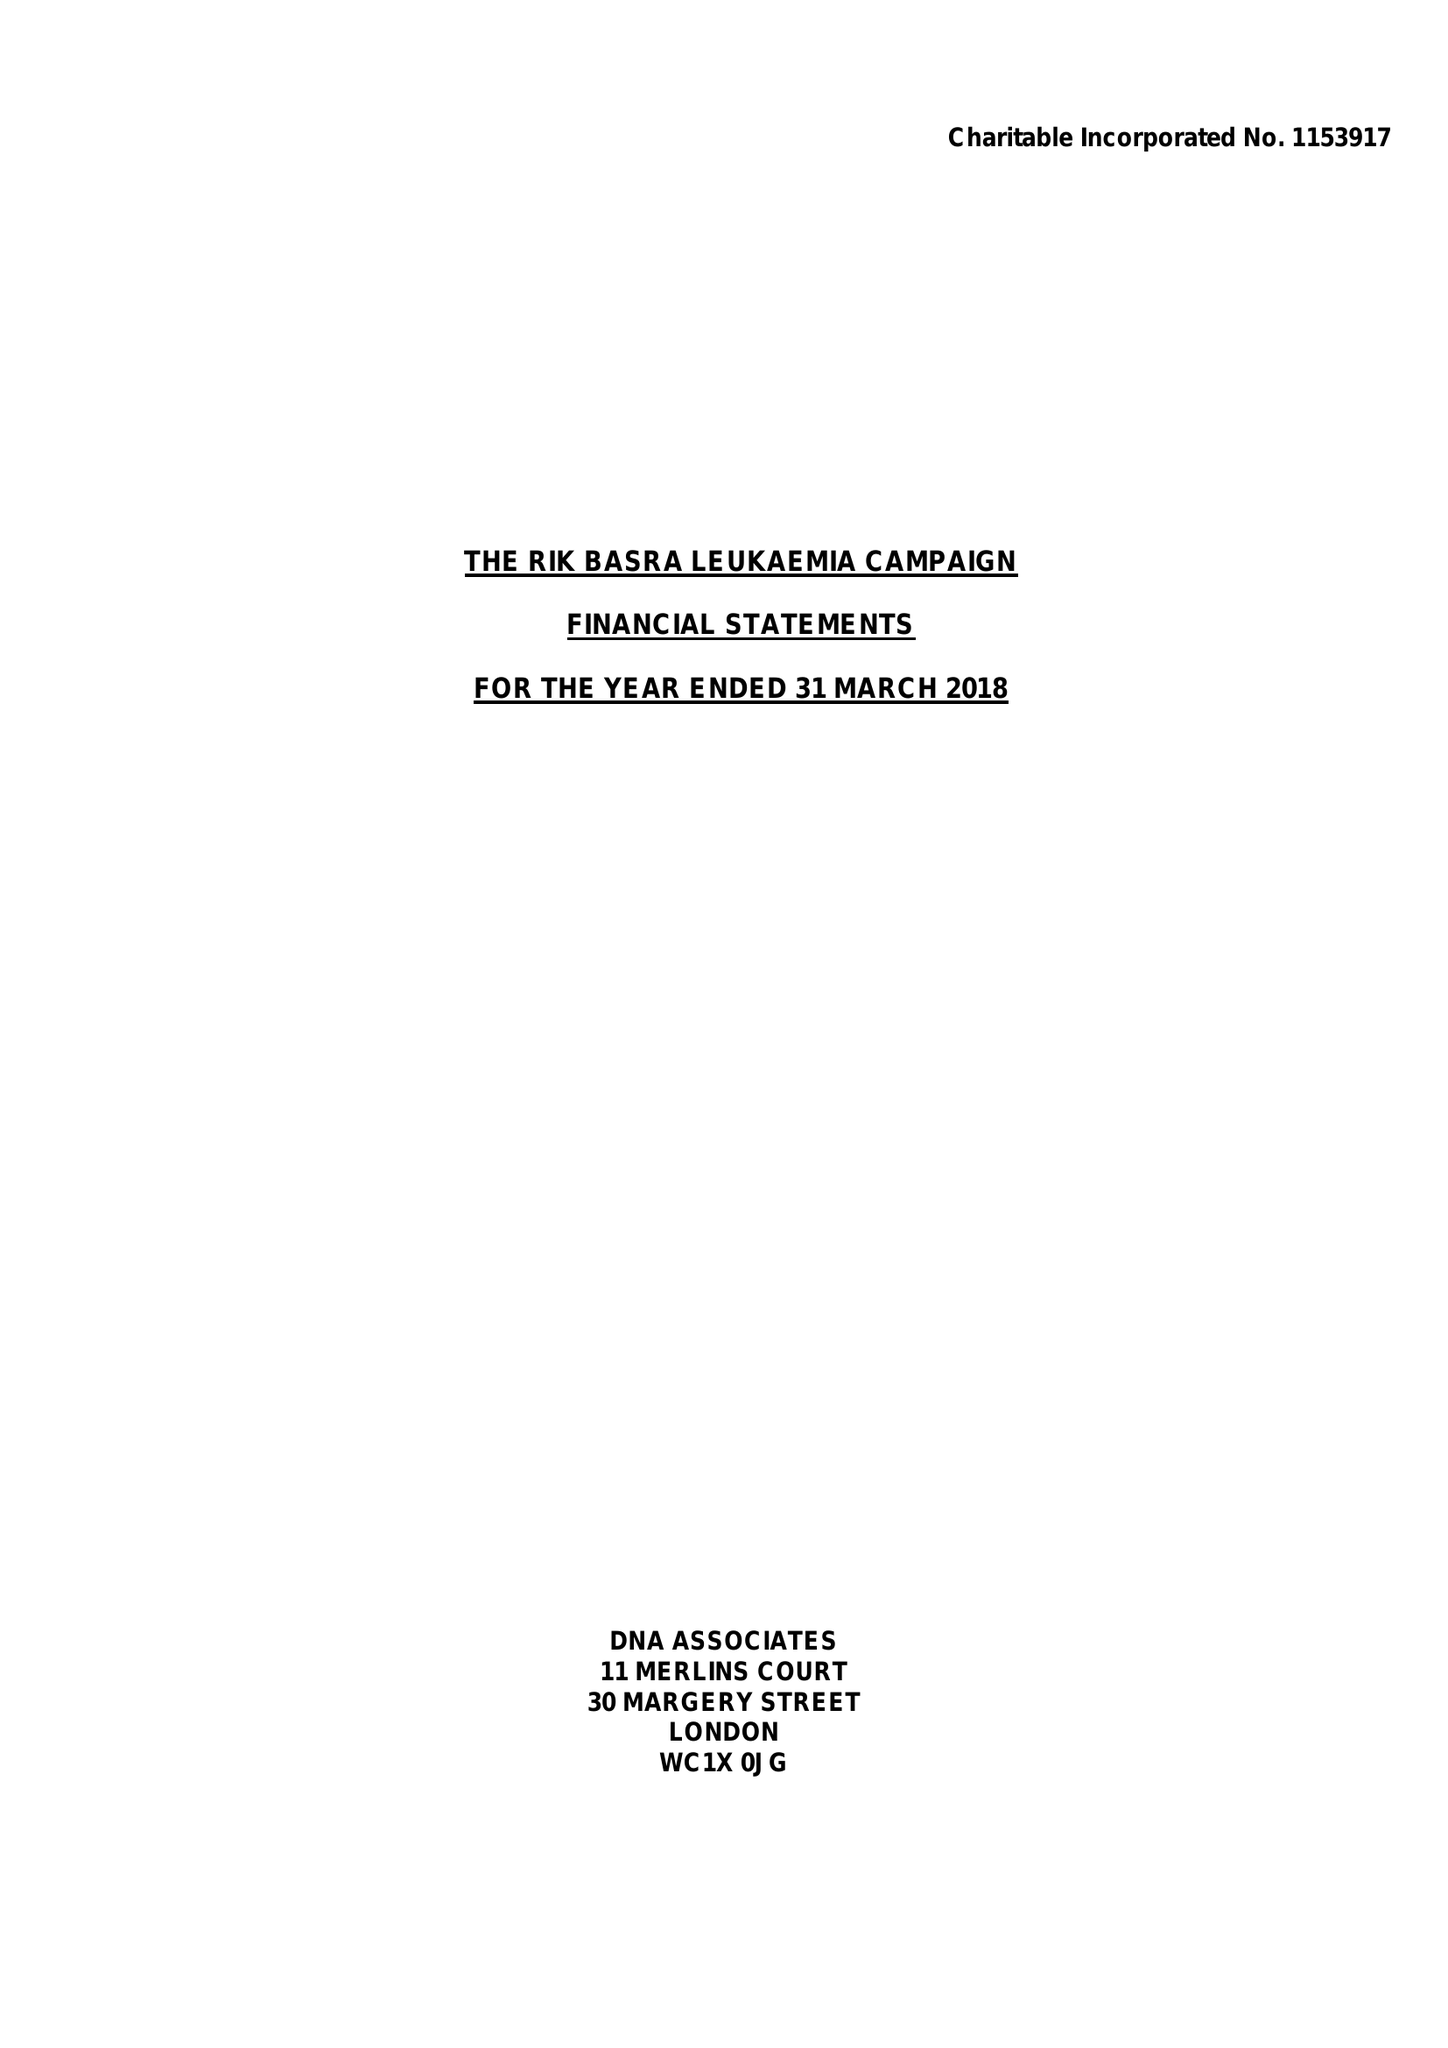What is the value for the report_date?
Answer the question using a single word or phrase. 2018-03-31 